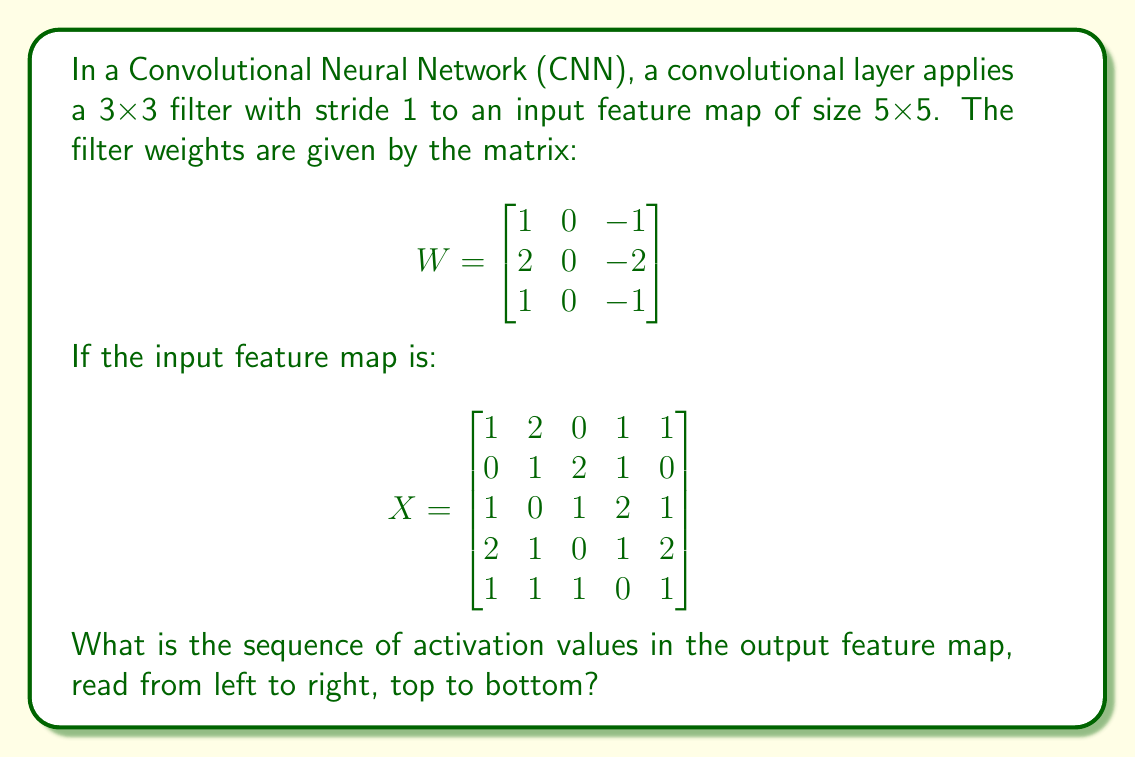Can you solve this math problem? To solve this problem, we need to perform convolution operations between the input feature map and the filter. Let's go through the steps:

1) The output feature map size will be 3x3 because:
   Output size = (Input size - Filter size) / Stride + 1
                = (5 - 3) / 1 + 1 = 3

2) We need to compute 9 values (3x3 output). For each output value, we perform element-wise multiplication of the filter with a 3x3 section of the input, then sum the results.

3) Let's compute each value:

   For position (1,1):
   $$\begin{bmatrix}
   1 & 2 & 0 \\
   0 & 1 & 2 \\
   1 & 0 & 1
   \end{bmatrix} \circ 
   \begin{bmatrix}
   1 & 0 & -1 \\
   2 & 0 & -2 \\
   1 & 0 & -1
   \end{bmatrix} = 1(1) + 2(0) + 0(-1) + 0(2) + 1(0) + 2(-2) + 1(1) + 0(0) + 1(-1) = -2$$

   For position (1,2):
   $$\begin{bmatrix}
   2 & 0 & 1 \\
   1 & 2 & 1 \\
   0 & 1 & 2
   \end{bmatrix} \circ W = 2(1) + 0(0) + 1(-1) + 1(2) + 2(0) + 1(-2) + 0(1) + 1(0) + 2(-1) = -1$$

   For position (1,3):
   $$\begin{bmatrix}
   0 & 1 & 1 \\
   2 & 1 & 0 \\
   1 & 2 & 1
   \end{bmatrix} \circ W = 0(1) + 1(0) + 1(-1) + 2(2) + 1(0) + 0(-2) + 1(1) + 2(0) + 1(-1) = 3$$

   For position (2,1):
   $$\begin{bmatrix}
   0 & 1 & 2 \\
   1 & 0 & 1 \\
   2 & 1 & 0
   \end{bmatrix} \circ W = 0(1) + 1(0) + 2(-1) + 1(2) + 0(0) + 1(-2) + 2(1) + 1(0) + 0(-1) = -1$$

   For position (2,2):
   $$\begin{bmatrix}
   1 & 2 & 1 \\
   0 & 1 & 2 \\
   1 & 0 & 1
   \end{bmatrix} \circ W = 1(1) + 2(0) + 1(-1) + 0(2) + 1(0) + 2(-2) + 1(1) + 0(0) + 1(-1) = -3$$

   For position (2,3):
   $$\begin{bmatrix}
   2 & 1 & 0 \\
   1 & 2 & 1 \\
   0 & 1 & 2
   \end{bmatrix} \circ W = 2(1) + 1(0) + 0(-1) + 1(2) + 2(0) + 1(-2) + 0(1) + 1(0) + 2(-1) = 1$$

   For position (3,1):
   $$\begin{bmatrix}
   1 & 0 & 1 \\
   2 & 1 & 0 \\
   1 & 1 & 1
   \end{bmatrix} \circ W = 1(1) + 0(0) + 1(-1) + 2(2) + 1(0) + 0(-2) + 1(1) + 1(0) + 1(-1) = 3$$

   For position (3,2):
   $$\begin{bmatrix}
   0 & 1 & 2 \\
   1 & 0 & 1 \\
   1 & 1 & 0
   \end{bmatrix} \circ W = 0(1) + 1(0) + 2(-1) + 1(2) + 0(0) + 1(-2) + 1(1) + 1(0) + 0(-1) = -1$$

   For position (3,3):
   $$\begin{bmatrix}
   1 & 2 & 1 \\
   0 & 1 & 2 \\
   1 & 0 & 1
   \end{bmatrix} \circ W = 1(1) + 2(0) + 1(-1) + 0(2) + 1(0) + 2(-2) + 1(1) + 0(0) + 1(-1) = -3$$

4) The resulting output feature map is:
   $$\begin{bmatrix}
   -2 & -1 & 3 \\
   -1 & -3 & 1 \\
   3 & -1 & -3
   \end{bmatrix}$$

5) Reading from left to right, top to bottom, the sequence is: -2, -1, 3, -1, -3, 1, 3, -1, -3
Answer: -2, -1, 3, -1, -3, 1, 3, -1, -3 